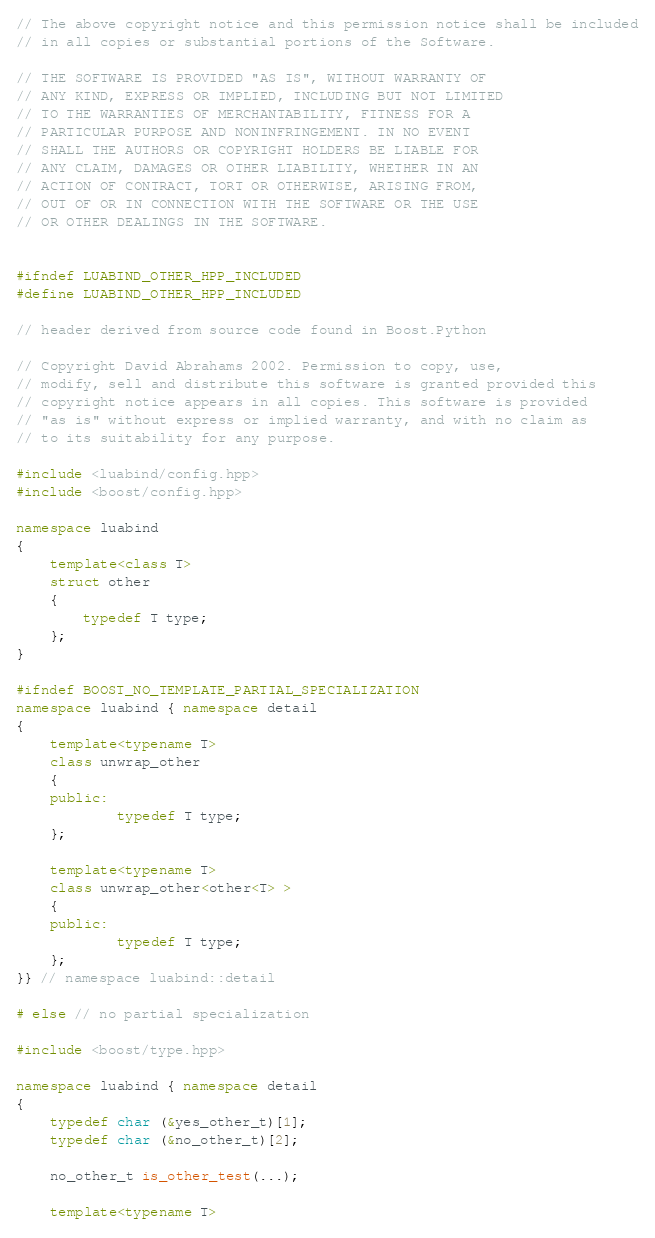Convert code to text. <code><loc_0><loc_0><loc_500><loc_500><_C++_>
// The above copyright notice and this permission notice shall be included
// in all copies or substantial portions of the Software.

// THE SOFTWARE IS PROVIDED "AS IS", WITHOUT WARRANTY OF
// ANY KIND, EXPRESS OR IMPLIED, INCLUDING BUT NOT LIMITED
// TO THE WARRANTIES OF MERCHANTABILITY, FITNESS FOR A
// PARTICULAR PURPOSE AND NONINFRINGEMENT. IN NO EVENT
// SHALL THE AUTHORS OR COPYRIGHT HOLDERS BE LIABLE FOR
// ANY CLAIM, DAMAGES OR OTHER LIABILITY, WHETHER IN AN
// ACTION OF CONTRACT, TORT OR OTHERWISE, ARISING FROM,
// OUT OF OR IN CONNECTION WITH THE SOFTWARE OR THE USE
// OR OTHER DEALINGS IN THE SOFTWARE.


#ifndef LUABIND_OTHER_HPP_INCLUDED
#define LUABIND_OTHER_HPP_INCLUDED

// header derived from source code found in Boost.Python

// Copyright David Abrahams 2002. Permission to copy, use,
// modify, sell and distribute this software is granted provided this
// copyright notice appears in all copies. This software is provided
// "as is" without express or implied warranty, and with no claim as
// to its suitability for any purpose.

#include <luabind/config.hpp>
#include <boost/config.hpp>

namespace luabind
{
	template<class T>
	struct other
	{
		typedef T type;
	};
}

#ifndef BOOST_NO_TEMPLATE_PARTIAL_SPECIALIZATION
namespace luabind { namespace detail
{
	template<typename T>
	class unwrap_other
	{
	public:
			typedef T type;
	};

	template<typename T>
	class unwrap_other<other<T> >
	{
	public:
			typedef T type;
	};
}} // namespace luabind::detail

# else // no partial specialization

#include <boost/type.hpp>

namespace luabind { namespace detail
{
	typedef char (&yes_other_t)[1];
	typedef char (&no_other_t)[2];

	no_other_t is_other_test(...);

	template<typename T></code> 